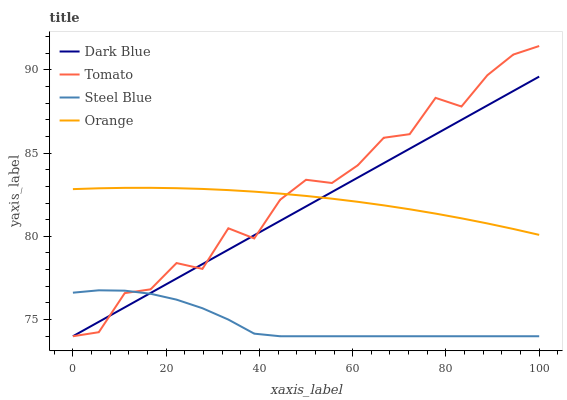Does Steel Blue have the minimum area under the curve?
Answer yes or no. Yes. Does Tomato have the maximum area under the curve?
Answer yes or no. Yes. Does Dark Blue have the minimum area under the curve?
Answer yes or no. No. Does Dark Blue have the maximum area under the curve?
Answer yes or no. No. Is Dark Blue the smoothest?
Answer yes or no. Yes. Is Tomato the roughest?
Answer yes or no. Yes. Is Orange the smoothest?
Answer yes or no. No. Is Orange the roughest?
Answer yes or no. No. Does Tomato have the lowest value?
Answer yes or no. Yes. Does Orange have the lowest value?
Answer yes or no. No. Does Tomato have the highest value?
Answer yes or no. Yes. Does Dark Blue have the highest value?
Answer yes or no. No. Is Steel Blue less than Orange?
Answer yes or no. Yes. Is Orange greater than Steel Blue?
Answer yes or no. Yes. Does Orange intersect Dark Blue?
Answer yes or no. Yes. Is Orange less than Dark Blue?
Answer yes or no. No. Is Orange greater than Dark Blue?
Answer yes or no. No. Does Steel Blue intersect Orange?
Answer yes or no. No. 